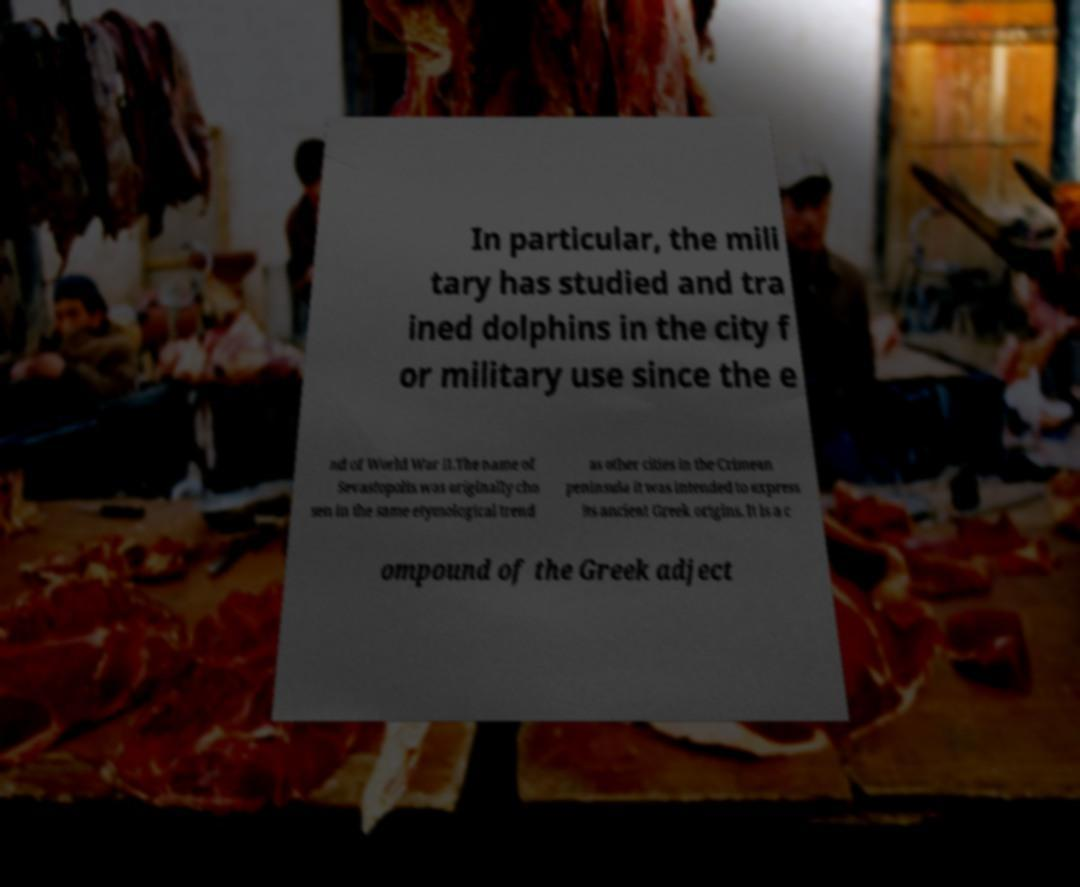I need the written content from this picture converted into text. Can you do that? In particular, the mili tary has studied and tra ined dolphins in the city f or military use since the e nd of World War II.The name of Sevastopolis was originally cho sen in the same etymological trend as other cities in the Crimean peninsula it was intended to express its ancient Greek origins. It is a c ompound of the Greek adject 